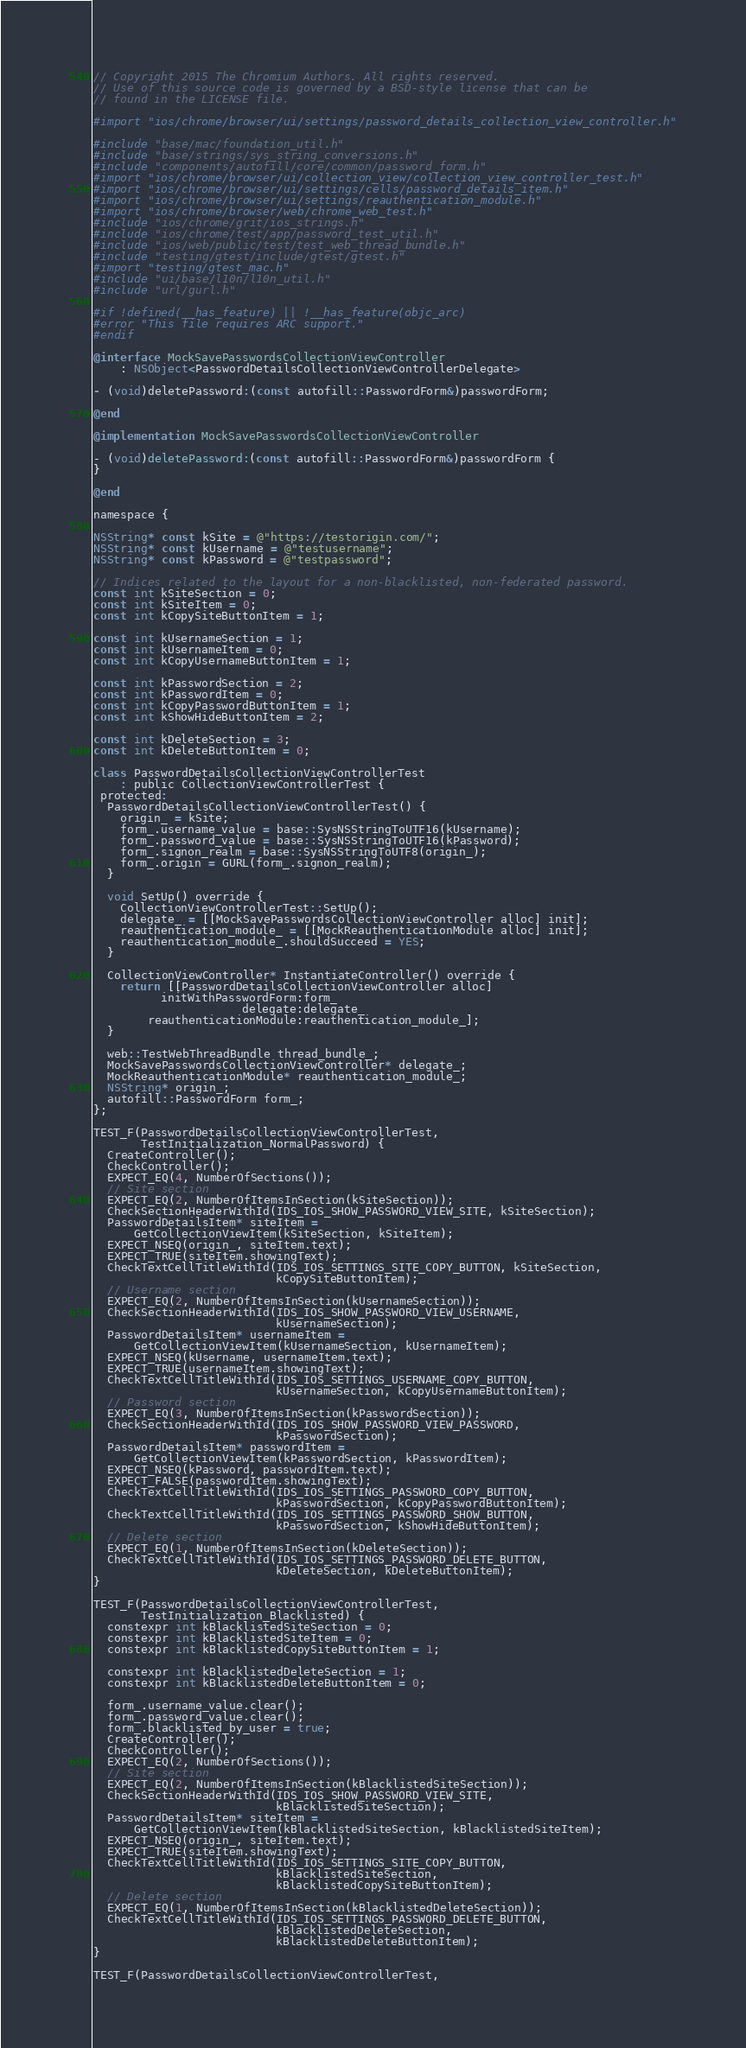<code> <loc_0><loc_0><loc_500><loc_500><_ObjectiveC_>// Copyright 2015 The Chromium Authors. All rights reserved.
// Use of this source code is governed by a BSD-style license that can be
// found in the LICENSE file.

#import "ios/chrome/browser/ui/settings/password_details_collection_view_controller.h"

#include "base/mac/foundation_util.h"
#include "base/strings/sys_string_conversions.h"
#include "components/autofill/core/common/password_form.h"
#import "ios/chrome/browser/ui/collection_view/collection_view_controller_test.h"
#import "ios/chrome/browser/ui/settings/cells/password_details_item.h"
#import "ios/chrome/browser/ui/settings/reauthentication_module.h"
#import "ios/chrome/browser/web/chrome_web_test.h"
#include "ios/chrome/grit/ios_strings.h"
#include "ios/chrome/test/app/password_test_util.h"
#include "ios/web/public/test/test_web_thread_bundle.h"
#include "testing/gtest/include/gtest/gtest.h"
#import "testing/gtest_mac.h"
#include "ui/base/l10n/l10n_util.h"
#include "url/gurl.h"

#if !defined(__has_feature) || !__has_feature(objc_arc)
#error "This file requires ARC support."
#endif

@interface MockSavePasswordsCollectionViewController
    : NSObject<PasswordDetailsCollectionViewControllerDelegate>

- (void)deletePassword:(const autofill::PasswordForm&)passwordForm;

@end

@implementation MockSavePasswordsCollectionViewController

- (void)deletePassword:(const autofill::PasswordForm&)passwordForm {
}

@end

namespace {

NSString* const kSite = @"https://testorigin.com/";
NSString* const kUsername = @"testusername";
NSString* const kPassword = @"testpassword";

// Indices related to the layout for a non-blacklisted, non-federated password.
const int kSiteSection = 0;
const int kSiteItem = 0;
const int kCopySiteButtonItem = 1;

const int kUsernameSection = 1;
const int kUsernameItem = 0;
const int kCopyUsernameButtonItem = 1;

const int kPasswordSection = 2;
const int kPasswordItem = 0;
const int kCopyPasswordButtonItem = 1;
const int kShowHideButtonItem = 2;

const int kDeleteSection = 3;
const int kDeleteButtonItem = 0;

class PasswordDetailsCollectionViewControllerTest
    : public CollectionViewControllerTest {
 protected:
  PasswordDetailsCollectionViewControllerTest() {
    origin_ = kSite;
    form_.username_value = base::SysNSStringToUTF16(kUsername);
    form_.password_value = base::SysNSStringToUTF16(kPassword);
    form_.signon_realm = base::SysNSStringToUTF8(origin_);
    form_.origin = GURL(form_.signon_realm);
  }

  void SetUp() override {
    CollectionViewControllerTest::SetUp();
    delegate_ = [[MockSavePasswordsCollectionViewController alloc] init];
    reauthentication_module_ = [[MockReauthenticationModule alloc] init];
    reauthentication_module_.shouldSucceed = YES;
  }

  CollectionViewController* InstantiateController() override {
    return [[PasswordDetailsCollectionViewController alloc]
          initWithPasswordForm:form_
                      delegate:delegate_
        reauthenticationModule:reauthentication_module_];
  }

  web::TestWebThreadBundle thread_bundle_;
  MockSavePasswordsCollectionViewController* delegate_;
  MockReauthenticationModule* reauthentication_module_;
  NSString* origin_;
  autofill::PasswordForm form_;
};

TEST_F(PasswordDetailsCollectionViewControllerTest,
       TestInitialization_NormalPassword) {
  CreateController();
  CheckController();
  EXPECT_EQ(4, NumberOfSections());
  // Site section
  EXPECT_EQ(2, NumberOfItemsInSection(kSiteSection));
  CheckSectionHeaderWithId(IDS_IOS_SHOW_PASSWORD_VIEW_SITE, kSiteSection);
  PasswordDetailsItem* siteItem =
      GetCollectionViewItem(kSiteSection, kSiteItem);
  EXPECT_NSEQ(origin_, siteItem.text);
  EXPECT_TRUE(siteItem.showingText);
  CheckTextCellTitleWithId(IDS_IOS_SETTINGS_SITE_COPY_BUTTON, kSiteSection,
                           kCopySiteButtonItem);
  // Username section
  EXPECT_EQ(2, NumberOfItemsInSection(kUsernameSection));
  CheckSectionHeaderWithId(IDS_IOS_SHOW_PASSWORD_VIEW_USERNAME,
                           kUsernameSection);
  PasswordDetailsItem* usernameItem =
      GetCollectionViewItem(kUsernameSection, kUsernameItem);
  EXPECT_NSEQ(kUsername, usernameItem.text);
  EXPECT_TRUE(usernameItem.showingText);
  CheckTextCellTitleWithId(IDS_IOS_SETTINGS_USERNAME_COPY_BUTTON,
                           kUsernameSection, kCopyUsernameButtonItem);
  // Password section
  EXPECT_EQ(3, NumberOfItemsInSection(kPasswordSection));
  CheckSectionHeaderWithId(IDS_IOS_SHOW_PASSWORD_VIEW_PASSWORD,
                           kPasswordSection);
  PasswordDetailsItem* passwordItem =
      GetCollectionViewItem(kPasswordSection, kPasswordItem);
  EXPECT_NSEQ(kPassword, passwordItem.text);
  EXPECT_FALSE(passwordItem.showingText);
  CheckTextCellTitleWithId(IDS_IOS_SETTINGS_PASSWORD_COPY_BUTTON,
                           kPasswordSection, kCopyPasswordButtonItem);
  CheckTextCellTitleWithId(IDS_IOS_SETTINGS_PASSWORD_SHOW_BUTTON,
                           kPasswordSection, kShowHideButtonItem);
  // Delete section
  EXPECT_EQ(1, NumberOfItemsInSection(kDeleteSection));
  CheckTextCellTitleWithId(IDS_IOS_SETTINGS_PASSWORD_DELETE_BUTTON,
                           kDeleteSection, kDeleteButtonItem);
}

TEST_F(PasswordDetailsCollectionViewControllerTest,
       TestInitialization_Blacklisted) {
  constexpr int kBlacklistedSiteSection = 0;
  constexpr int kBlacklistedSiteItem = 0;
  constexpr int kBlacklistedCopySiteButtonItem = 1;

  constexpr int kBlacklistedDeleteSection = 1;
  constexpr int kBlacklistedDeleteButtonItem = 0;

  form_.username_value.clear();
  form_.password_value.clear();
  form_.blacklisted_by_user = true;
  CreateController();
  CheckController();
  EXPECT_EQ(2, NumberOfSections());
  // Site section
  EXPECT_EQ(2, NumberOfItemsInSection(kBlacklistedSiteSection));
  CheckSectionHeaderWithId(IDS_IOS_SHOW_PASSWORD_VIEW_SITE,
                           kBlacklistedSiteSection);
  PasswordDetailsItem* siteItem =
      GetCollectionViewItem(kBlacklistedSiteSection, kBlacklistedSiteItem);
  EXPECT_NSEQ(origin_, siteItem.text);
  EXPECT_TRUE(siteItem.showingText);
  CheckTextCellTitleWithId(IDS_IOS_SETTINGS_SITE_COPY_BUTTON,
                           kBlacklistedSiteSection,
                           kBlacklistedCopySiteButtonItem);
  // Delete section
  EXPECT_EQ(1, NumberOfItemsInSection(kBlacklistedDeleteSection));
  CheckTextCellTitleWithId(IDS_IOS_SETTINGS_PASSWORD_DELETE_BUTTON,
                           kBlacklistedDeleteSection,
                           kBlacklistedDeleteButtonItem);
}

TEST_F(PasswordDetailsCollectionViewControllerTest,</code> 